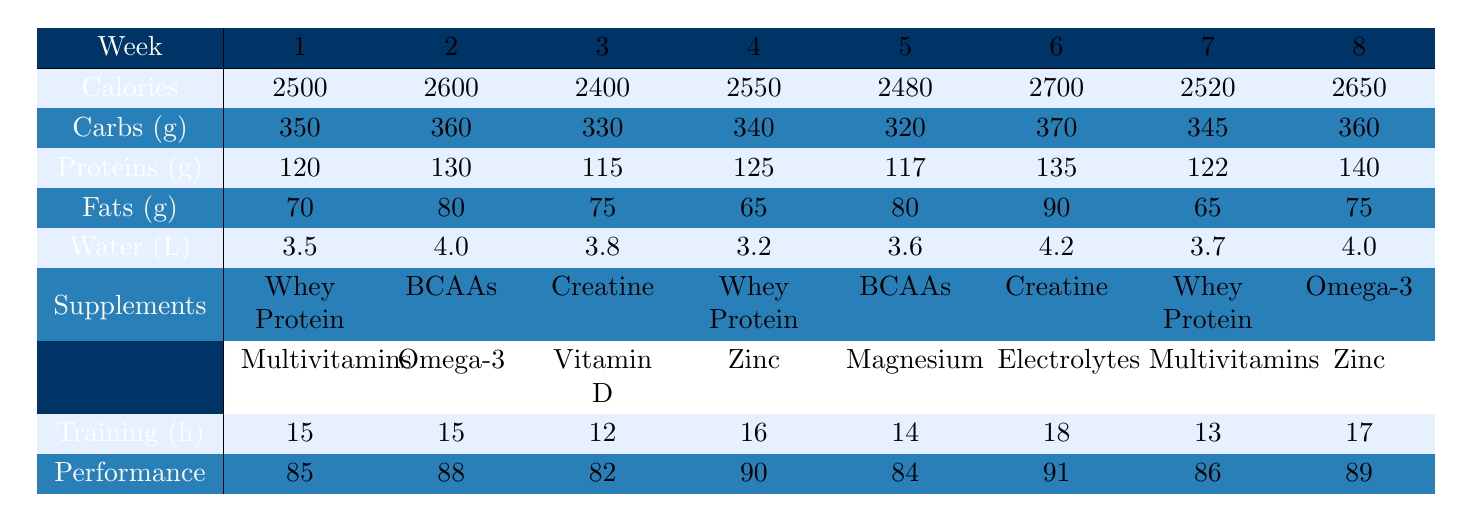What was the highest performance score recorded in the table? The highest performance score appears in Week 6 with a score of 91, as I can see by comparing all the performance scores listed in the table.
Answer: 91 Which week had the lowest calorie intake? By looking at the calorie intake values across the weeks, Week 3 has the lowest value at 2400 calories.
Answer: Week 3 How many training hours were recorded in Week 4? The table lists 16 training hours for Week 4 directly under the training hours row.
Answer: 16 What is the total amount of carbohydrates consumed across all weeks? The total carbohydrates can be calculated by summing the individual weekly carbohydrates: 350 + 360 + 330 + 340 + 320 + 370 + 345 + 360 = 2,725 grams.
Answer: 2725 g In which week did the athlete consume the most protein? Upon checking the protein intake for each week, Week 8 has the highest protein amount at 140 grams.
Answer: Week 8 Did the athlete consume more fats in Week 6 than in Week 3? Yes, in Week 6, 90 grams of fat were consumed compared to 75 grams in Week 3, so this statement is true.
Answer: Yes What was the average water intake over the 8 weeks? To find the average water intake, sum all the water intakes (3.5 + 4.0 + 3.8 + 3.2 + 3.6 + 4.2 + 3.7 + 4.0 = 30.0 liters) and divide by the number of weeks (30.0 / 8 = 3.75 liters).
Answer: 3.75 L How many times was whey protein included in the supplements? Whey protein was included in the supplements for Weeks 1, 4, 6, and 7, which makes a total of 4 occurrences.
Answer: 4 times Was the increase in calories from Week 1 to Week 6 accompanied by an increase in performance score? Yes, calories increased from 2500 (Week 1) to 2700 (Week 6), and performance score also increased from 85 to 91, indicating a correlation.
Answer: Yes What is the difference in performance score between the highest and lowest week? The highest performance score is 91 (Week 6) and the lowest is 82 (Week 3); thus, the difference is 91 - 82 = 9.
Answer: 9 Which week had the highest carbohydrate intake and what was the amount? Week 6 had the highest carbohydrate intake of 370 grams, as seen when looking through the weekly carbohydrate values.
Answer: Week 6, 370 g 